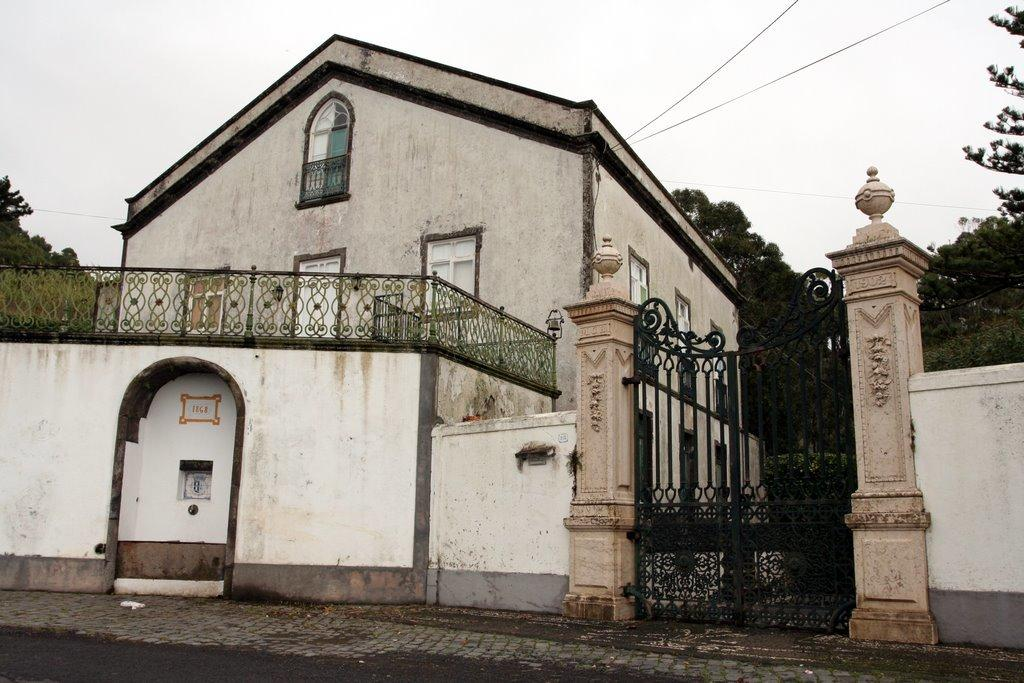What type of structure is visible in the image? There is a building in the image. What is the color of the gate in front of the building? The gate is black-colored. What is the primary function of the gate? The gate is used for entering the building. What type of vegetation is present on both sides of the building? Trees are present on both sides of the building. Where is the faucet located in the image? There is no faucet present in the image. What type of patch can be seen on the trees in the image? There are no patches visible on the trees in the image. 